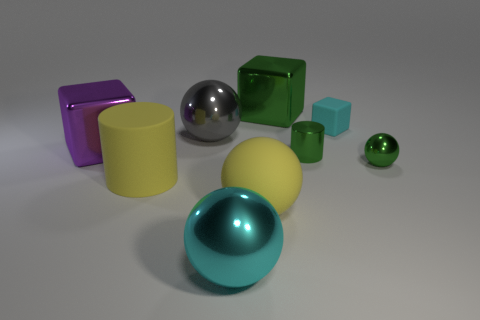Subtract all gray spheres. How many spheres are left? 3 Add 1 blue matte cylinders. How many objects exist? 10 Subtract 1 balls. How many balls are left? 3 Subtract all brown cubes. How many yellow cylinders are left? 1 Subtract all green blocks. Subtract all big things. How many objects are left? 2 Add 7 yellow objects. How many yellow objects are left? 9 Add 6 big purple shiny objects. How many big purple shiny objects exist? 7 Subtract all green cubes. How many cubes are left? 2 Subtract 1 yellow cylinders. How many objects are left? 8 Subtract all blocks. How many objects are left? 6 